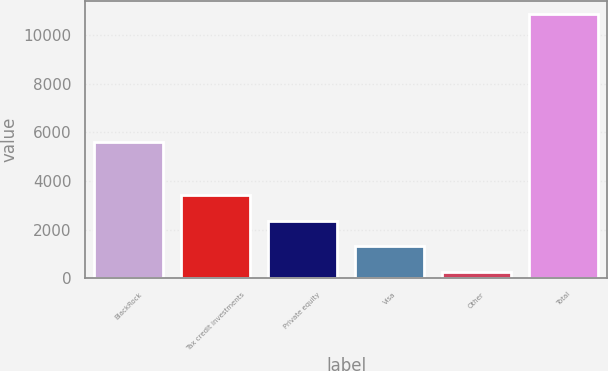<chart> <loc_0><loc_0><loc_500><loc_500><bar_chart><fcel>BlackRock<fcel>Tax credit investments<fcel>Private equity<fcel>Visa<fcel>Other<fcel>Total<nl><fcel>5614<fcel>3434.6<fcel>2371.4<fcel>1308.2<fcel>245<fcel>10877<nl></chart> 